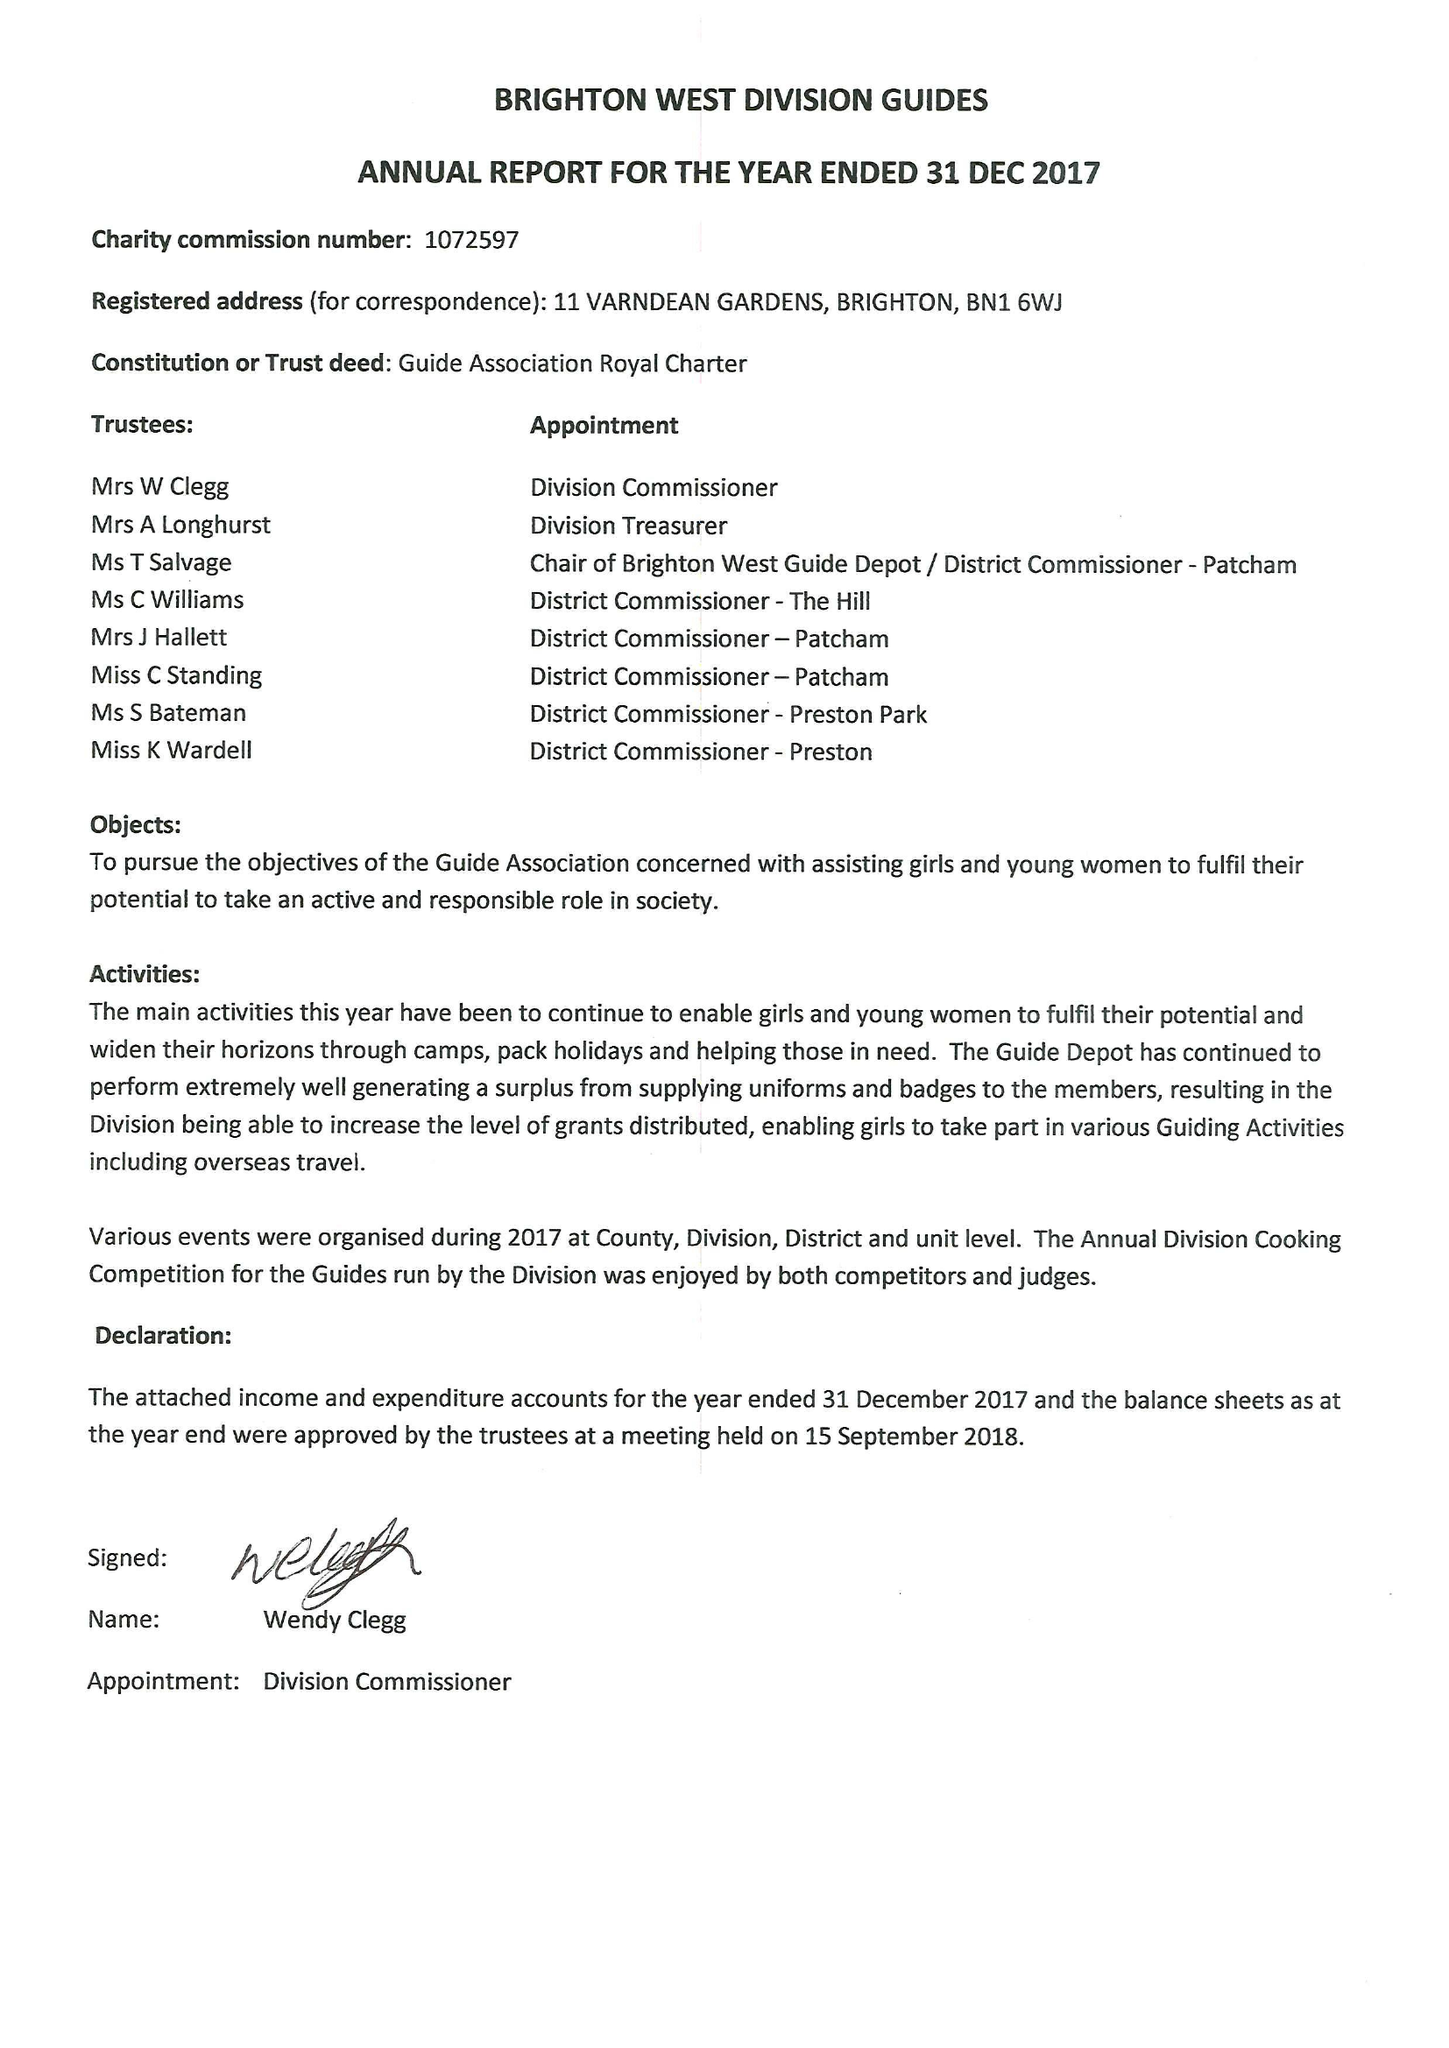What is the value for the charity_name?
Answer the question using a single word or phrase. Brighton West Division Guides 